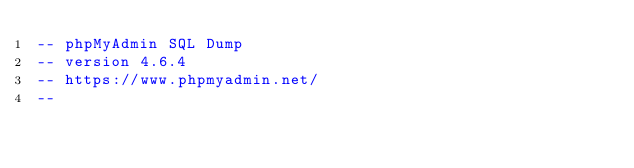<code> <loc_0><loc_0><loc_500><loc_500><_SQL_>-- phpMyAdmin SQL Dump
-- version 4.6.4
-- https://www.phpmyadmin.net/
--</code> 